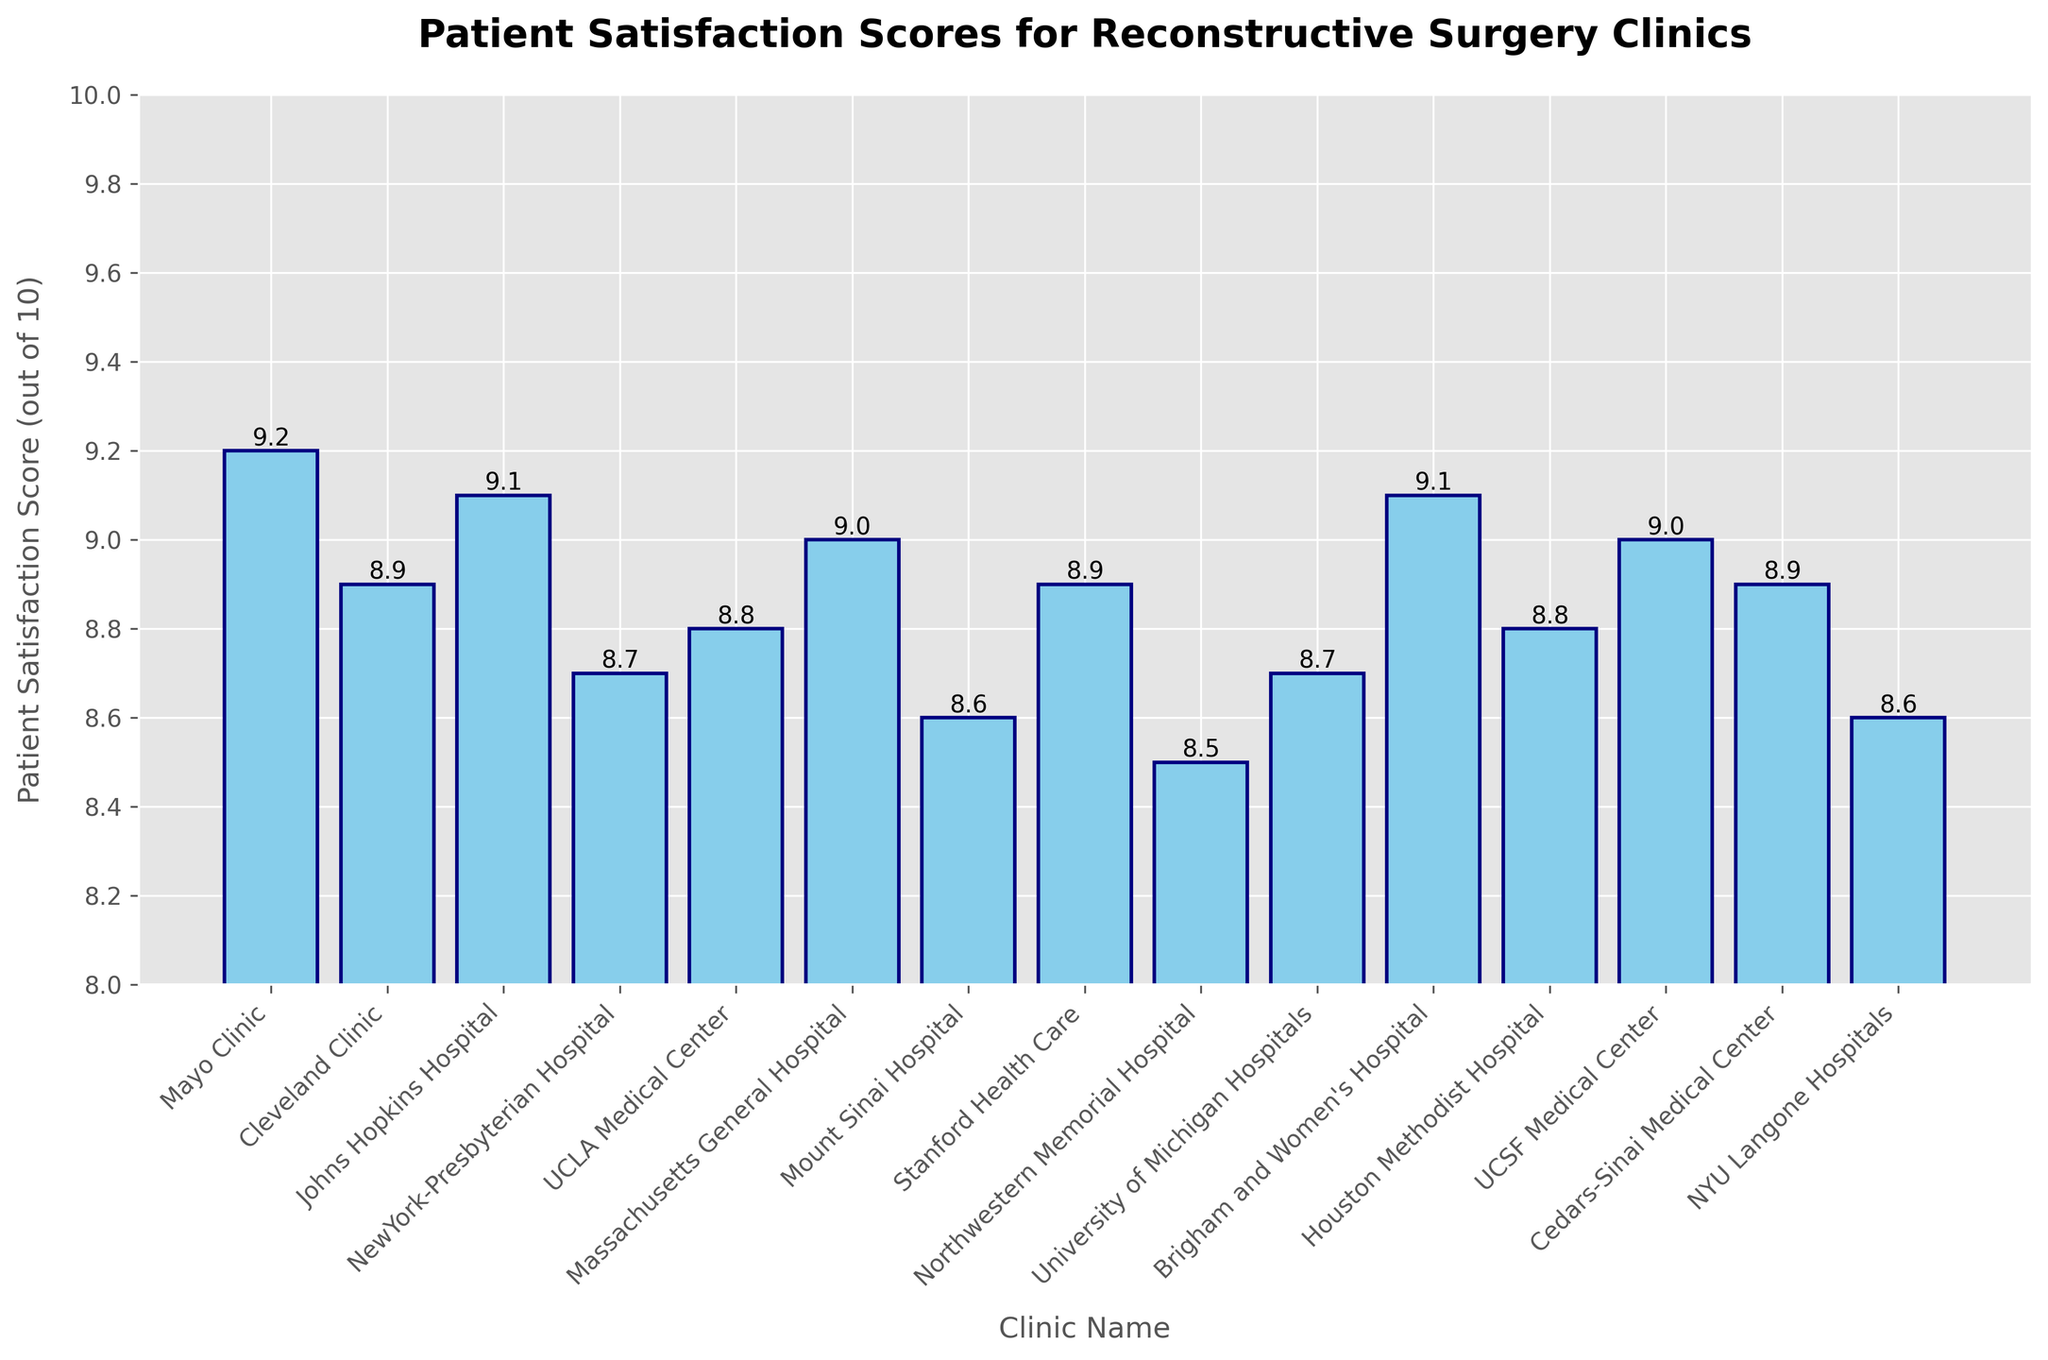Which clinic has the highest patient satisfaction score? The bar chart shows that the Mayo Clinic and Brigham and Women's Hospital both have the highest bar with a score of 9.2.
Answer: Mayo Clinic and Brigham and Women's Hospital Which clinic has the lowest patient satisfaction score? The shortest bar in the chart represents Northwestern Memorial Hospital with a score of 8.5.
Answer: Northwestern Memorial Hospital What is the average patient satisfaction score across all the clinics? To calculate the average, add all the satisfaction scores and divide by the number of clinics. (9.2 + 8.9 + 9.1 + 8.7 + 8.8 + 9.0 + 8.6 + 8.9 + 8.5 + 8.7 + 9.1 + 8.8 + 9.0 + 8.9 + 8.6) / 15 = 132.8 / 15 = 8.85.
Answer: 8.85 Which clinics have a patient satisfaction score above 9.0? Refer to the bars with heights above 9.0: Mayo Clinic, Johns Hopkins Hospital, Massachusetts General Hospital, Brigham and Women's Hospital, and UCSF Medical Center.
Answer: Mayo Clinic, Johns Hopkins Hospital, Massachusetts General Hospital, Brigham and Women's Hospital, UCSF Medical Center What is the difference in patient satisfaction score between the Mayo Clinic and Northwestern Memorial Hospital? The Mayo Clinic has a score of 9.2 and Northwestern Memorial Hospital has a score of 8.5. So the difference is 9.2 - 8.5 = 0.7.
Answer: 0.7 Which clinic has the smallest increase in score compared to NYU Langone Hospitals? NYU Langone Hospitals have a score of 8.6. Find the clinics with scores closest to 8.6 and determine which has the smallest increase: Mount Sinai Hospital (also 8.6) has an increase of 0.0.
Answer: Mount Sinai Hospital How many clinics scored exactly 8.9? There are four clinics with bars showing a score of 8.9: Cleveland Clinic, Stanford Health Care, Cedars-Sinai Medical Center, and one more.
Answer: 4 Are there any two clinics with the same patient satisfaction score of 9.1? The bars for Johns Hopkins Hospital and Brigham and Women's Hospital both reach 9.1.
Answer: Johns Hopkins Hospital and Brigham and Women's Hospital Compare the patient satisfaction scores between the University of Michigan Hospitals and NewYork-Presbyterian Hospital. Which is higher? The bar for University of Michigan Hospitals shows 8.7, and NewYork-Presbyterian Hospital also shows 8.7. They have equal scores.
Answer: Equal What is the total patient satisfaction score for Cleveland Clinic, Mayo Clinic, and Johns Hopkins Hospital combined? Add the scores of these clinics: Cleveland Clinic (8.9) + Mayo Clinic (9.2) + Johns Hopkins Hospital (9.1) = 27.2.
Answer: 27.2 